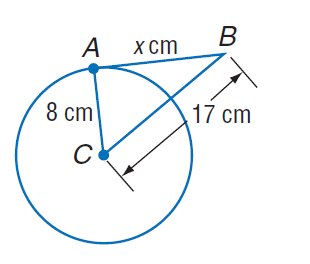Answer the mathemtical geometry problem and directly provide the correct option letter.
Question: Find x. Assume that segments that appear to be tangent are tangent.
Choices: A: 8 B: 15 C: 16 D: 17 B 